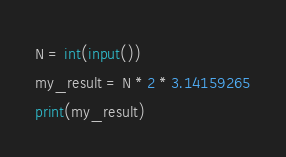<code> <loc_0><loc_0><loc_500><loc_500><_Python_>N = int(input())
my_result = N * 2 * 3.14159265
print(my_result)</code> 